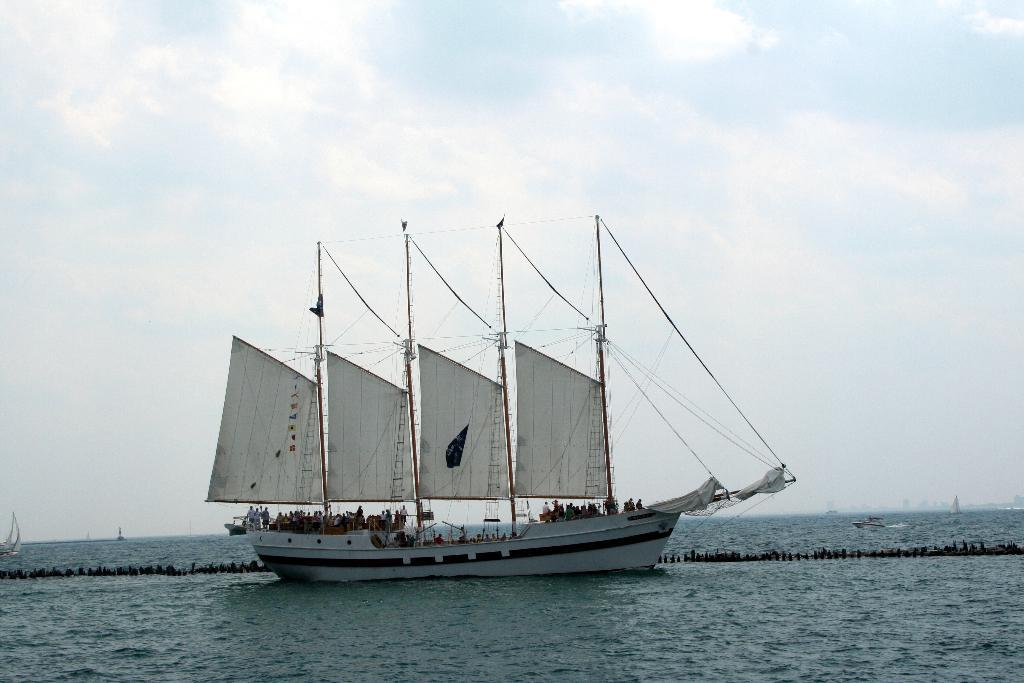What is the main subject of the image? The main subject of the image is a boat. Where is the boat located? The boat is on the water. What else can be seen in the image besides the boat? The sky is visible in the image. Can you describe the sky in the image? Clouds are present in the sky. What type of yarn is being used to create the branch in the image? There is no branch or yarn present in the image. 